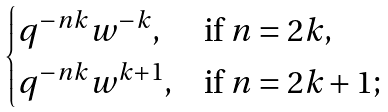<formula> <loc_0><loc_0><loc_500><loc_500>\begin{cases} q ^ { - n k } w ^ { - k } , & \text {if $n=2k$,} \\ q ^ { - n k } w ^ { k + 1 } , & \text {if $n=2k+1$;} \end{cases}</formula> 